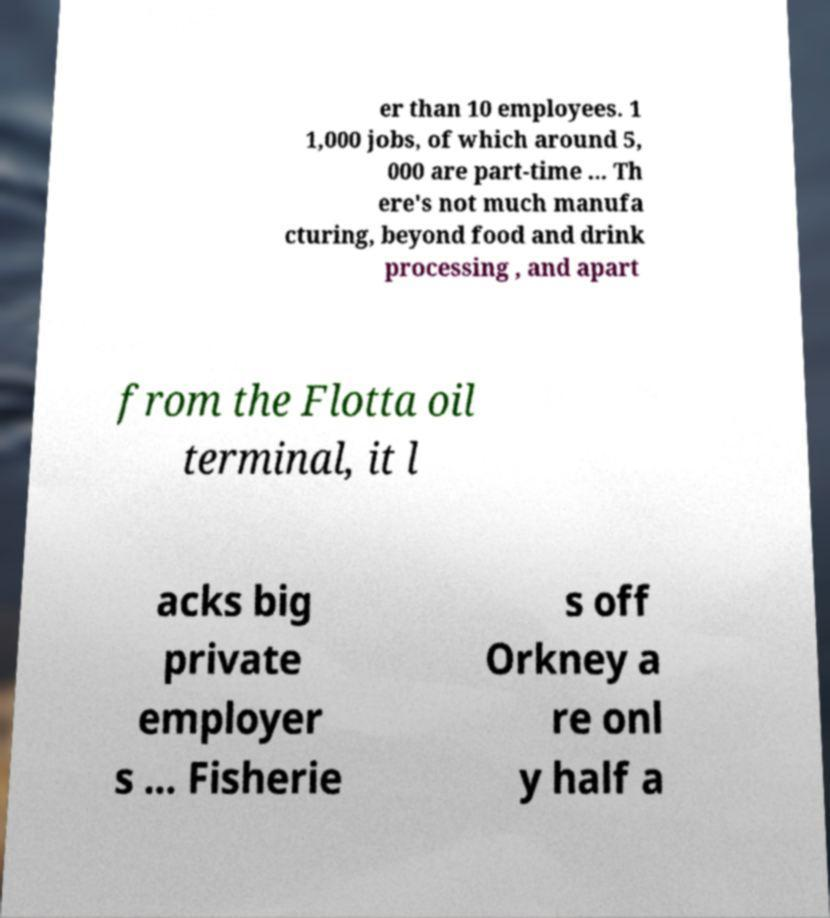Please read and relay the text visible in this image. What does it say? er than 10 employees. 1 1,000 jobs, of which around 5, 000 are part-time ... Th ere's not much manufa cturing, beyond food and drink processing , and apart from the Flotta oil terminal, it l acks big private employer s ... Fisherie s off Orkney a re onl y half a 